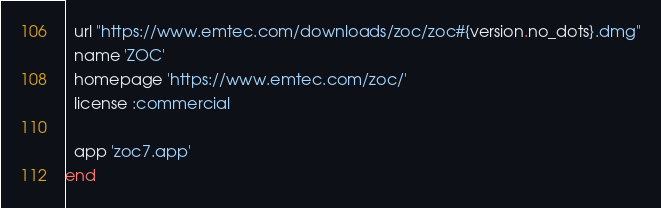Convert code to text. <code><loc_0><loc_0><loc_500><loc_500><_Ruby_>  url "https://www.emtec.com/downloads/zoc/zoc#{version.no_dots}.dmg"
  name 'ZOC'
  homepage 'https://www.emtec.com/zoc/'
  license :commercial

  app 'zoc7.app'
end
</code> 